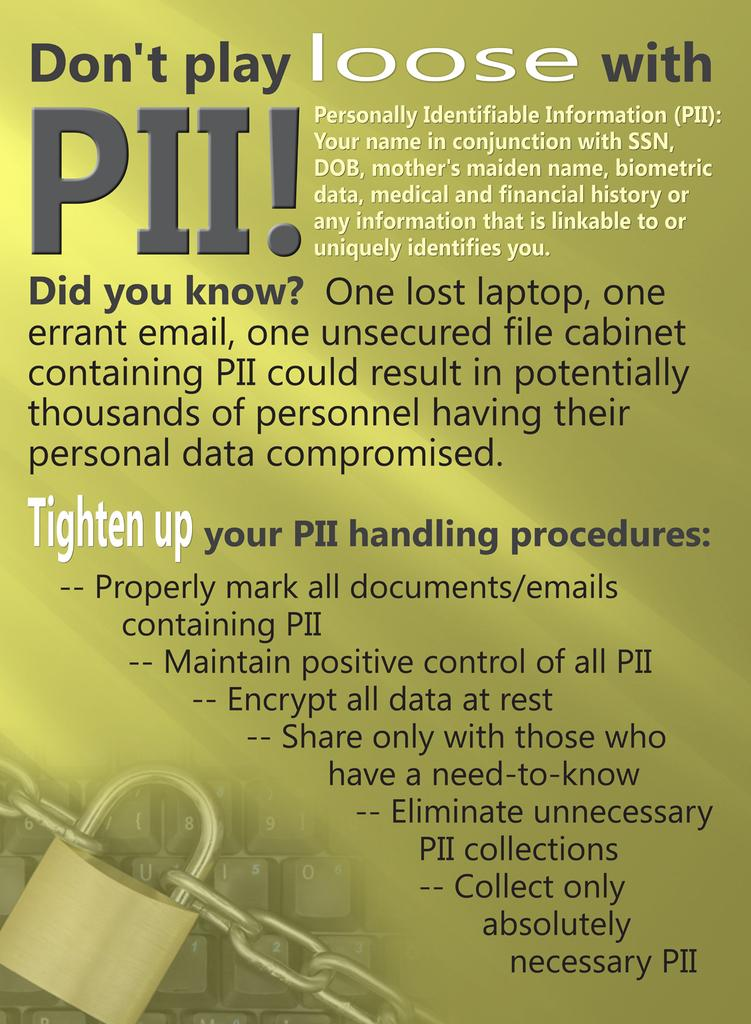Provide a one-sentence caption for the provided image. A flyer that states Don't Play loose with PII!. 